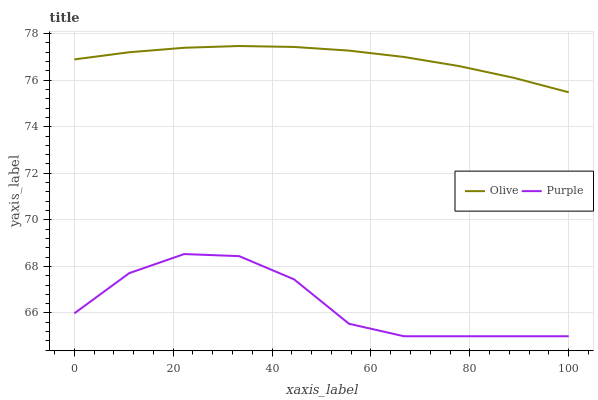Does Purple have the minimum area under the curve?
Answer yes or no. Yes. Does Olive have the maximum area under the curve?
Answer yes or no. Yes. Does Purple have the maximum area under the curve?
Answer yes or no. No. Is Olive the smoothest?
Answer yes or no. Yes. Is Purple the roughest?
Answer yes or no. Yes. Is Purple the smoothest?
Answer yes or no. No. Does Purple have the lowest value?
Answer yes or no. Yes. Does Olive have the highest value?
Answer yes or no. Yes. Does Purple have the highest value?
Answer yes or no. No. Is Purple less than Olive?
Answer yes or no. Yes. Is Olive greater than Purple?
Answer yes or no. Yes. Does Purple intersect Olive?
Answer yes or no. No. 